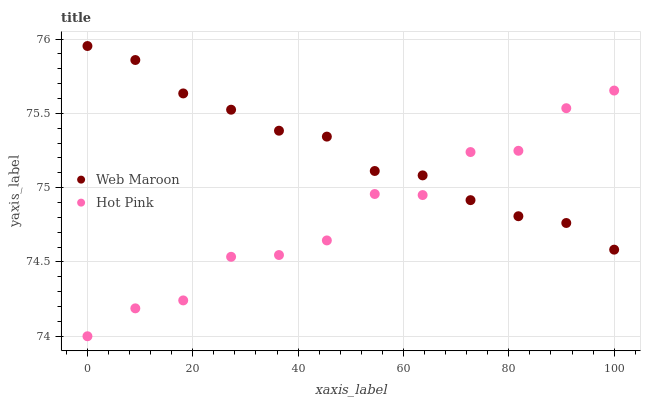Does Hot Pink have the minimum area under the curve?
Answer yes or no. Yes. Does Web Maroon have the maximum area under the curve?
Answer yes or no. Yes. Does Web Maroon have the minimum area under the curve?
Answer yes or no. No. Is Web Maroon the smoothest?
Answer yes or no. Yes. Is Hot Pink the roughest?
Answer yes or no. Yes. Is Web Maroon the roughest?
Answer yes or no. No. Does Hot Pink have the lowest value?
Answer yes or no. Yes. Does Web Maroon have the lowest value?
Answer yes or no. No. Does Web Maroon have the highest value?
Answer yes or no. Yes. Does Hot Pink intersect Web Maroon?
Answer yes or no. Yes. Is Hot Pink less than Web Maroon?
Answer yes or no. No. Is Hot Pink greater than Web Maroon?
Answer yes or no. No. 